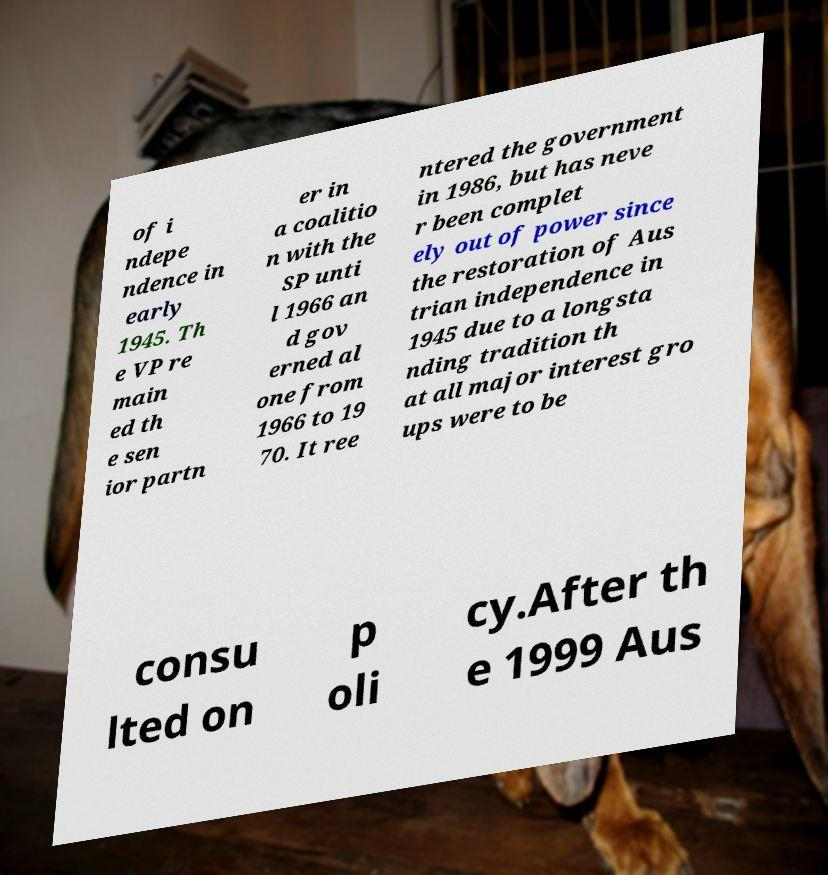Please identify and transcribe the text found in this image. of i ndepe ndence in early 1945. Th e VP re main ed th e sen ior partn er in a coalitio n with the SP unti l 1966 an d gov erned al one from 1966 to 19 70. It ree ntered the government in 1986, but has neve r been complet ely out of power since the restoration of Aus trian independence in 1945 due to a longsta nding tradition th at all major interest gro ups were to be consu lted on p oli cy.After th e 1999 Aus 